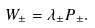<formula> <loc_0><loc_0><loc_500><loc_500>W _ { \pm } = \lambda _ { \pm } P _ { \pm } .</formula> 